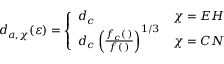Convert formula to latex. <formula><loc_0><loc_0><loc_500><loc_500>d _ { a , \chi } ( \varepsilon ) = \left \{ \begin{array} { l l } { d _ { c } } & { \chi = E H } \\ { d _ { c } \left ( \frac { f _ { c } ( \varepsilon ) } { f ( \varepsilon ) } \right ) ^ { 1 / 3 } } & { \chi = C N } \end{array}</formula> 